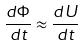<formula> <loc_0><loc_0><loc_500><loc_500>\frac { d \Phi } { d t } \approx \frac { d U } { d t }</formula> 